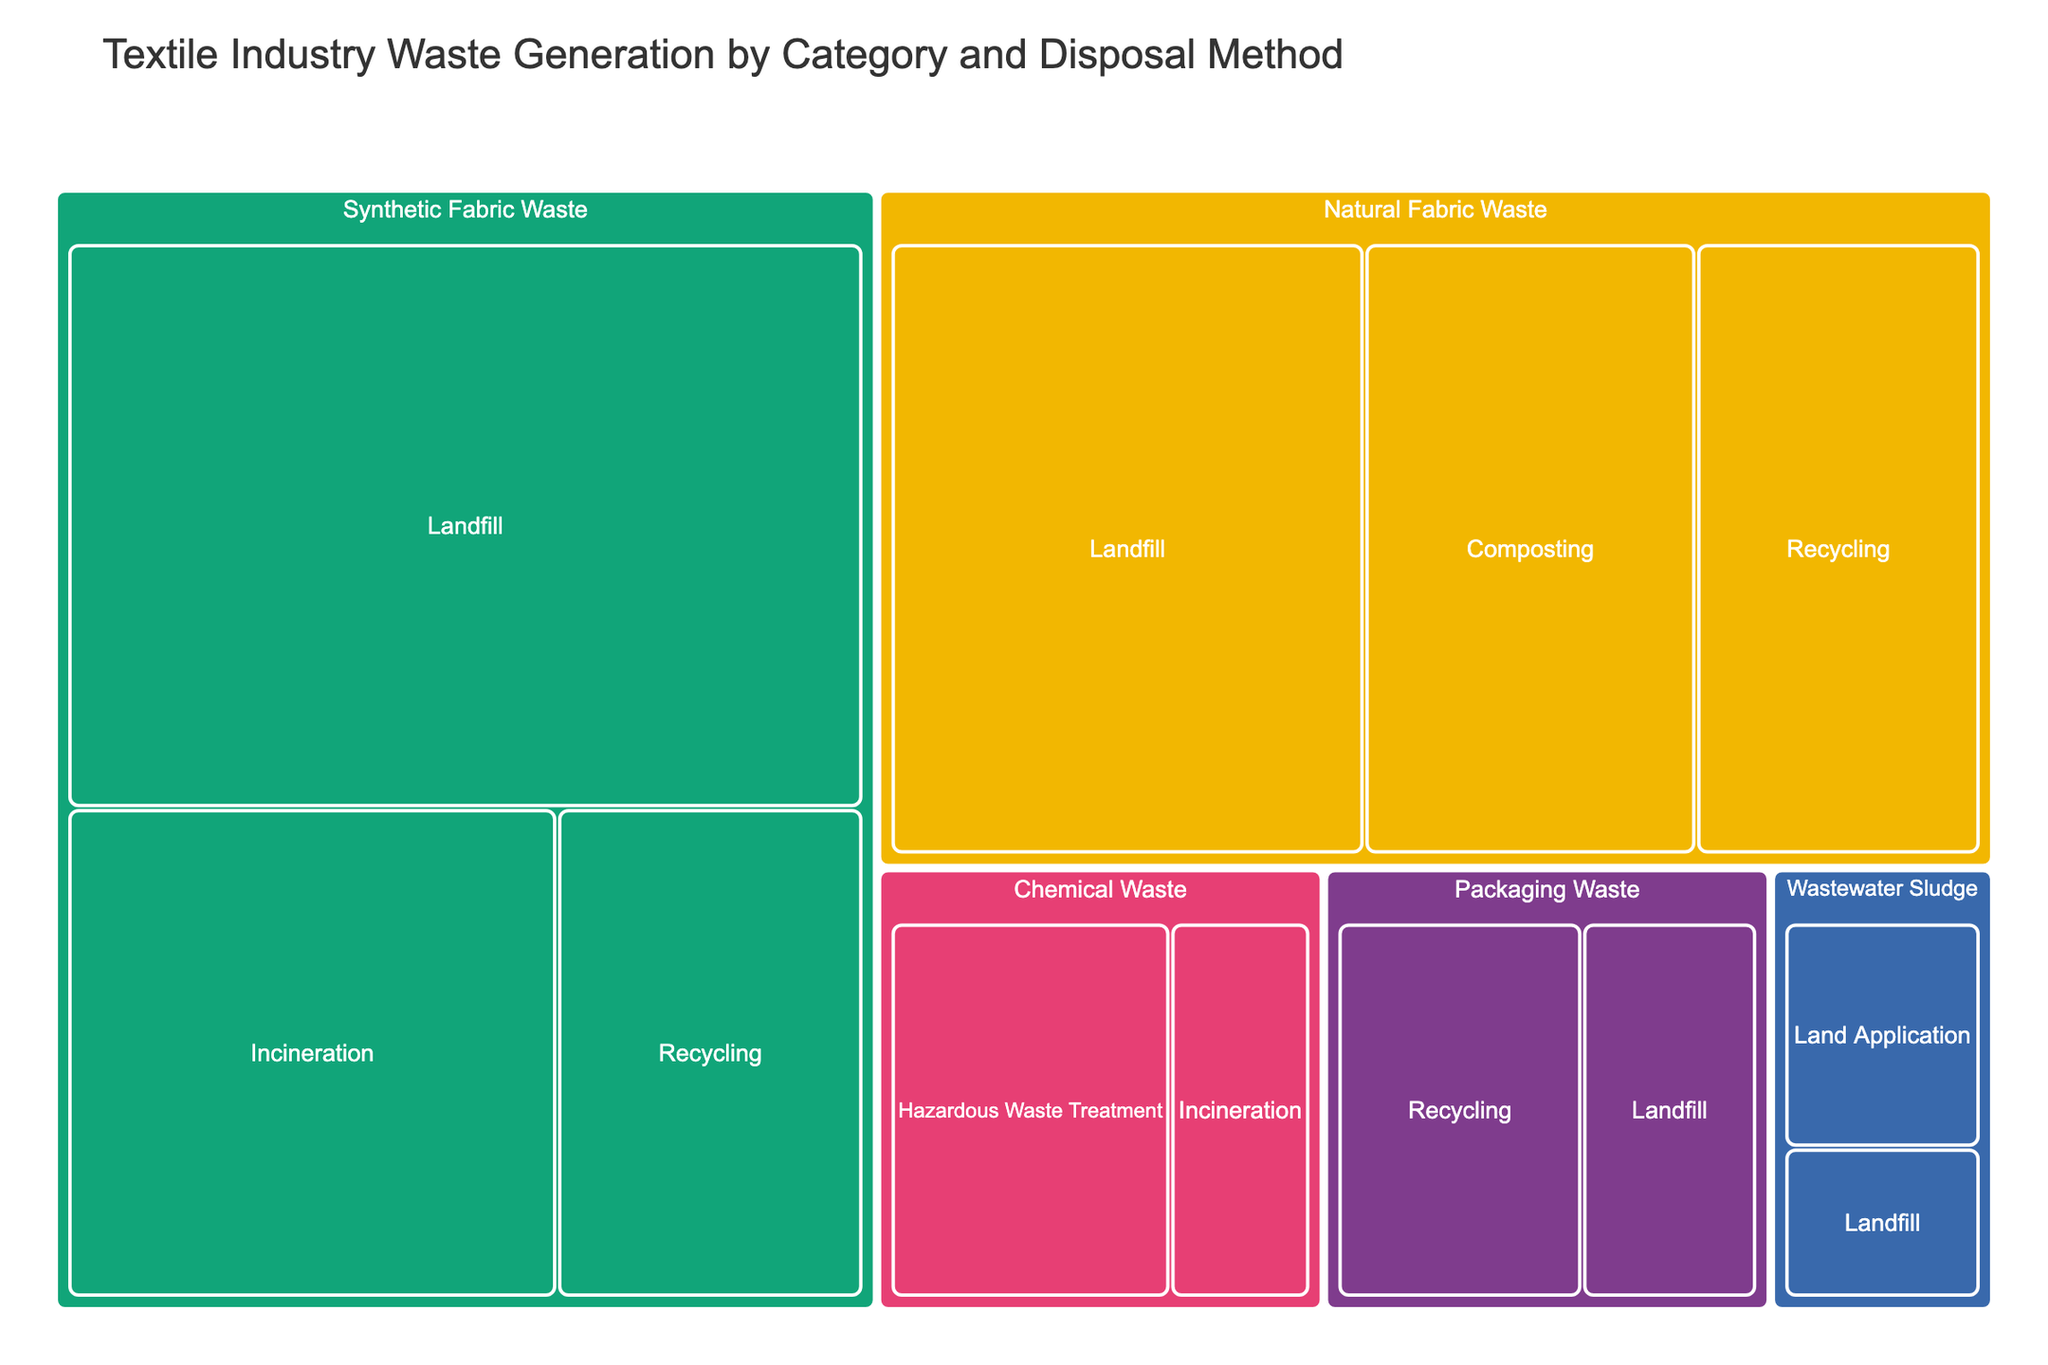What's the total amount of Synthetic Fabric Waste generated? Add up the values for all disposal methods of Synthetic Fabric Waste: 15000 tons (Landfill) + 8000 tons (Incineration) + 5000 tons (Recycling) = 28000 tons
Answer: 28000 tons What proportion of Natural Fabric Waste is composted? Divide the amount of composted Natural Fabric Waste by the total Natural Fabric Waste, then multiply by 100. The amount composted is 7000 tons and the total is 10000 (Landfill) + 7000 (Composting) + 6000 (Recycling) = 23000 tons. So, (7000 / 23000) * 100 ≈ 30.43%
Answer: 30.43% Which category has the highest waste generation for Landfill disposal? Compare the amounts in the Landfill disposal method for each category: Synthetic Fabric Waste (15000 tons), Natural Fabric Waste (10000 tons), Packaging Waste (2500 tons), and Wastewater Sludge (1200 tons). Synthetic Fabric Waste has the highest value.
Answer: Synthetic Fabric Waste Compare the total waste generated by Incineration for Synthetic Fabric Waste and Chemical Waste. Which is higher? Compare the Incineration amounts: Synthetic Fabric Waste is 8000 tons and Chemical Waste is 2000 tons. Synthetic Fabric Waste is higher.
Answer: Synthetic Fabric Waste How much more Synthetic Fabric Waste is sent to Landfill compared to Recycling? Subtract the amount of Synthetic Fabric Waste sent to Recycling from that sent to Landfill: 15000 tons (Landfill) - 5000 tons (Recycling) = 10000 tons
Answer: 10000 tons Which disposal method handles the least amount of Wastewater Sludge? Compare the amounts for Land Application and Landfill disposal methods for Wastewater Sludge: Land Application has 1800 tons and Landfill has 1200 tons. Landfill handles the least.
Answer: Landfill What is the total amount of Packaging Waste generated and how much of it is recycled? Add up the values for all disposal methods of Packaging Waste to get the total, then note the recycled amount: 3500 tons (Recycling) + 2500 tons (Landfill) = 6000 tons total. The amount recycled is 3500 tons.
Answer: 6000 tons, 3500 tons Compare the total recyclable waste of Natural Fabric Waste and Synthetic Fabric Waste. Which is higher? Compare the Recycling amounts: Natural Fabric Waste is 6000 tons and Synthetic Fabric Waste is 5000 tons. Natural Fabric Waste is higher.
Answer: Natural Fabric Waste What percentage of the total waste from the textile industry is generated by Chemical Waste? First, calculate the total waste amount: 28000 tons (Synthetic Fabric) + 23000 tons (Natural Fabric) + 6000 tons (Packaging) + 3000 tons (Wastewater Sludge) + 6000 tons (Chemical Waste) = 66000 tons. Then, (6000 tons / 66000 tons) * 100 = 9.09%
Answer: 9.09% 